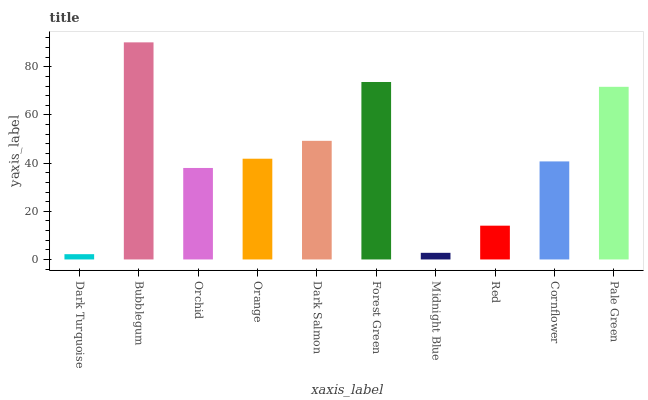Is Dark Turquoise the minimum?
Answer yes or no. Yes. Is Bubblegum the maximum?
Answer yes or no. Yes. Is Orchid the minimum?
Answer yes or no. No. Is Orchid the maximum?
Answer yes or no. No. Is Bubblegum greater than Orchid?
Answer yes or no. Yes. Is Orchid less than Bubblegum?
Answer yes or no. Yes. Is Orchid greater than Bubblegum?
Answer yes or no. No. Is Bubblegum less than Orchid?
Answer yes or no. No. Is Orange the high median?
Answer yes or no. Yes. Is Cornflower the low median?
Answer yes or no. Yes. Is Bubblegum the high median?
Answer yes or no. No. Is Pale Green the low median?
Answer yes or no. No. 